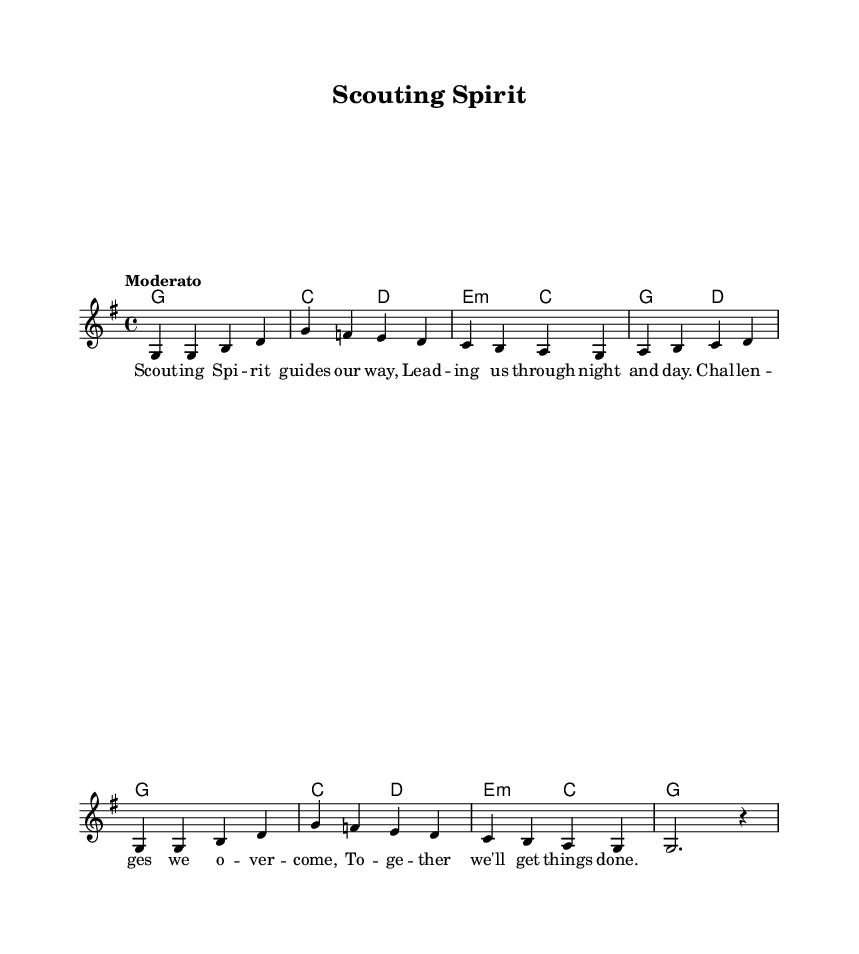What is the key signature of this music? The key signature is G major, which has one sharp (F#). This can be identified at the beginning of the score.
Answer: G major What is the time signature of this music? The time signature is 4/4, which is indicated right after the key signature at the beginning of the piece. This means there are four beats in each measure.
Answer: 4/4 What is the tempo marking of this music? The tempo marking is Moderato, which is usually interpreted as a moderate pace. This information is provided in the tempo instruction at the beginning.
Answer: Moderato How many measures does the melody contain? The melody contains eight measures, which can be counted by going through the notation and dividing it based on the bar lines shown on the staff.
Answer: Eight What type of chords are used in the harmonies? The harmonies include major and minor chords, as seen in the chord symbols provided in the score. This is deduced by identifying the root notes and the accidental sharps or flats where applicable.
Answer: Major and minor Which two notes are repeated in the melody at the start? The repeated notes at the start of the melody are G and G. This can be determined by analyzing the first two notes in the melody line, which appear consecutively.
Answer: G, G What is the primary theme of the lyrics? The primary theme of the lyrics is personal growth and overcoming challenges, as expressed through the words about guidance and teamwork. This is evident in the lyrical content that emphasizes leading through difficulties together.
Answer: Personal growth and overcoming challenges 